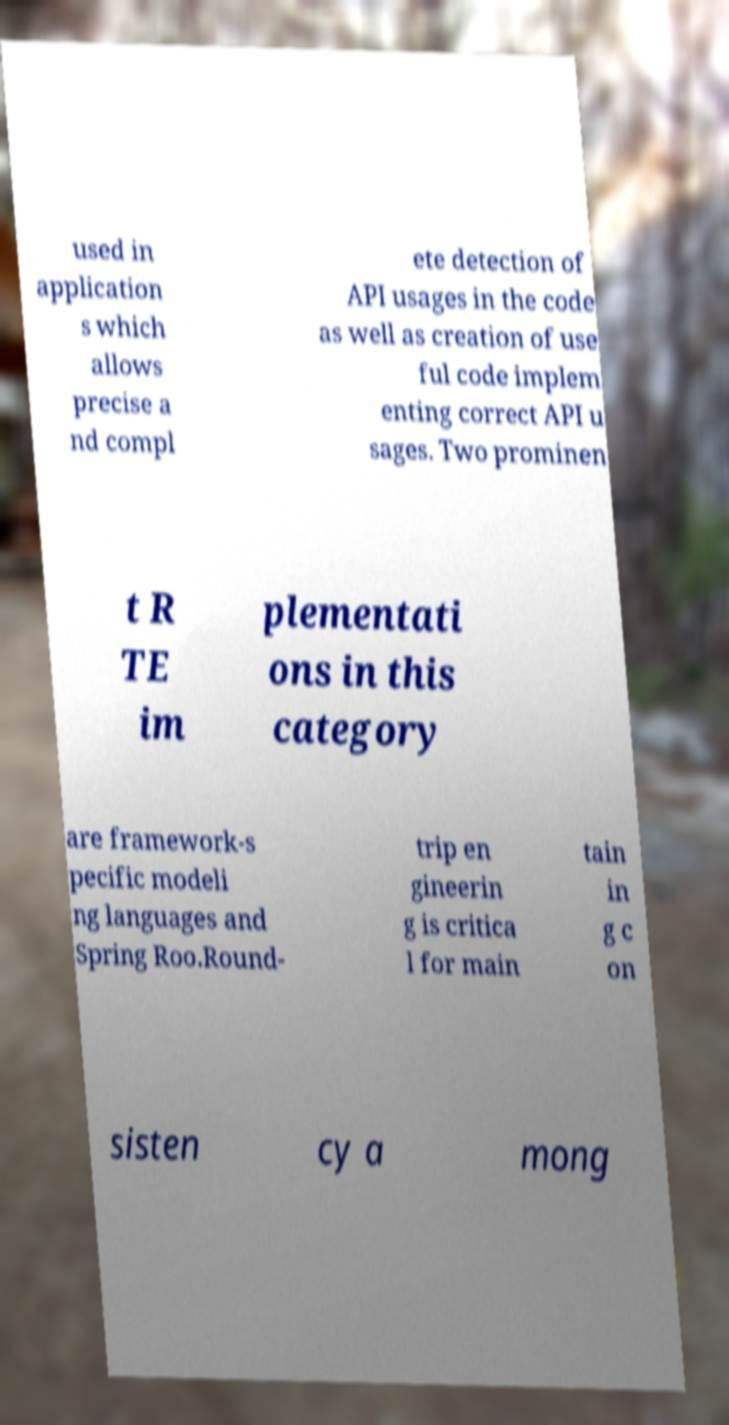Can you read and provide the text displayed in the image?This photo seems to have some interesting text. Can you extract and type it out for me? used in application s which allows precise a nd compl ete detection of API usages in the code as well as creation of use ful code implem enting correct API u sages. Two prominen t R TE im plementati ons in this category are framework-s pecific modeli ng languages and Spring Roo.Round- trip en gineerin g is critica l for main tain in g c on sisten cy a mong 